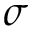Convert formula to latex. <formula><loc_0><loc_0><loc_500><loc_500>\sigma</formula> 